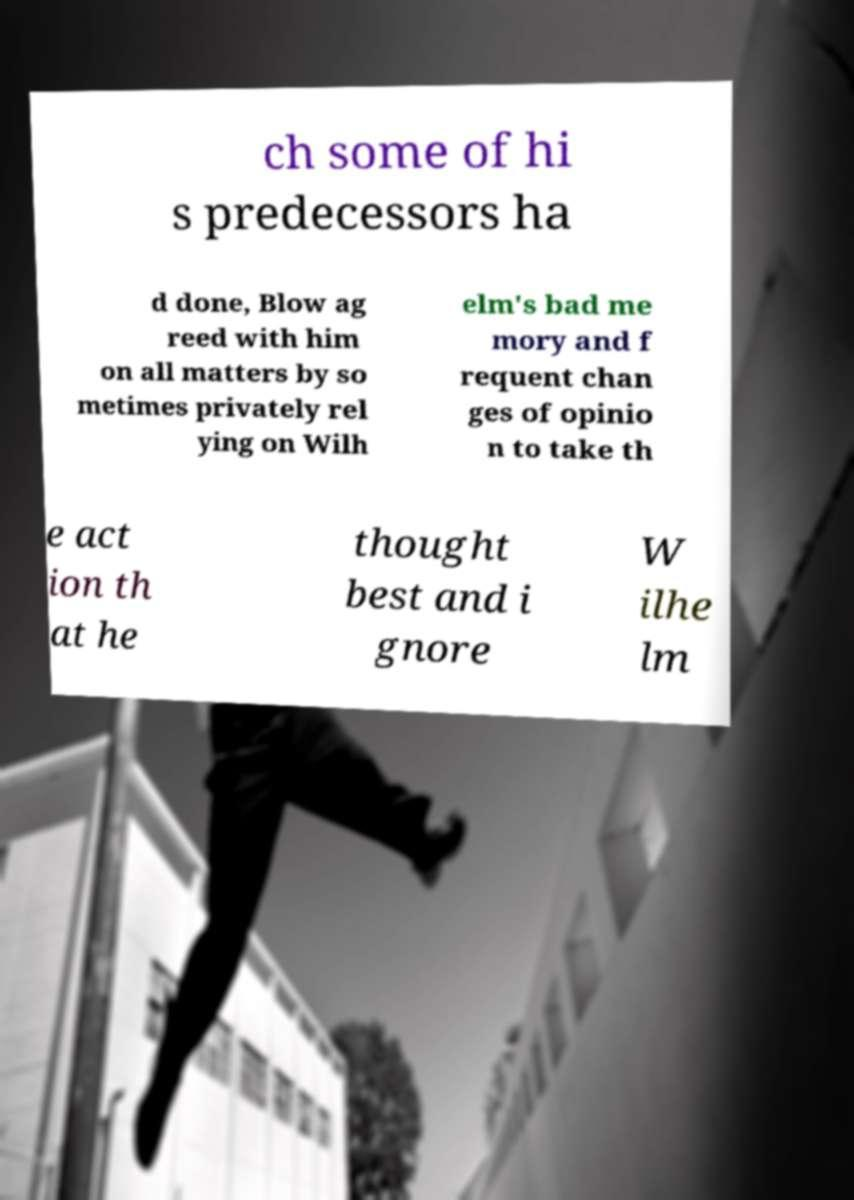Can you accurately transcribe the text from the provided image for me? ch some of hi s predecessors ha d done, Blow ag reed with him on all matters by so metimes privately rel ying on Wilh elm's bad me mory and f requent chan ges of opinio n to take th e act ion th at he thought best and i gnore W ilhe lm 